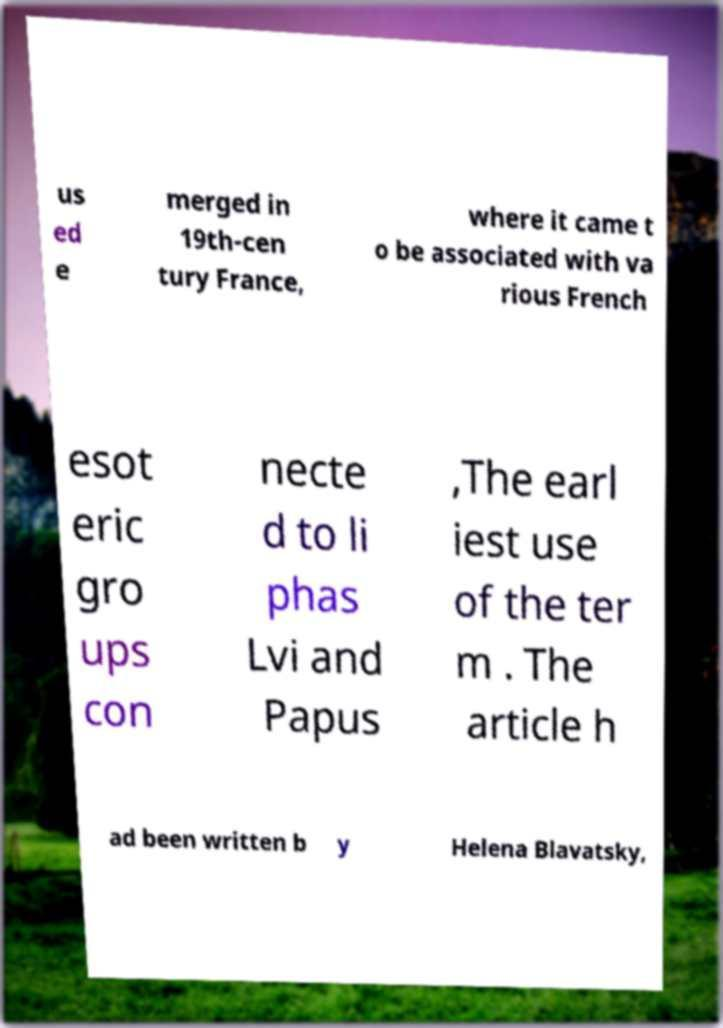Can you read and provide the text displayed in the image?This photo seems to have some interesting text. Can you extract and type it out for me? us ed e merged in 19th-cen tury France, where it came t o be associated with va rious French esot eric gro ups con necte d to li phas Lvi and Papus ,The earl iest use of the ter m . The article h ad been written b y Helena Blavatsky, 